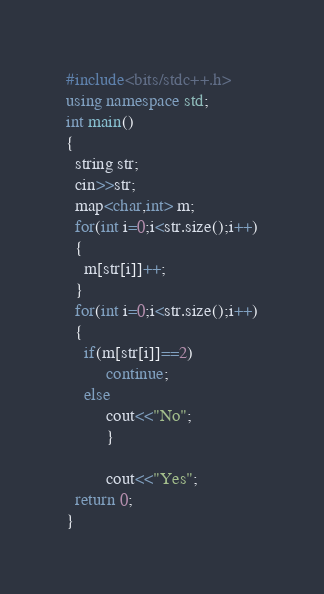Convert code to text. <code><loc_0><loc_0><loc_500><loc_500><_C++_>#include<bits/stdc++.h>
using namespace std;
int main()
{
  string str;
  cin>>str;
  map<char,int> m;
  for(int i=0;i<str.size();i++)
  {
    m[str[i]]++;
  }
  for(int i=0;i<str.size();i++)
  {
    if(m[str[i]]==2)
         continue;
    else
         cout<<"No";
         }
         
         cout<<"Yes";
  return 0;
}</code> 